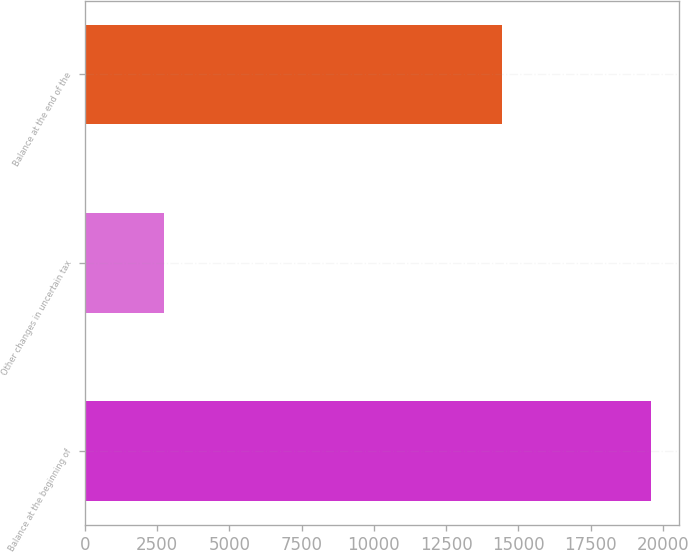<chart> <loc_0><loc_0><loc_500><loc_500><bar_chart><fcel>Balance at the beginning of<fcel>Other changes in uncertain tax<fcel>Balance at the end of the<nl><fcel>19596<fcel>2741<fcel>14450<nl></chart> 